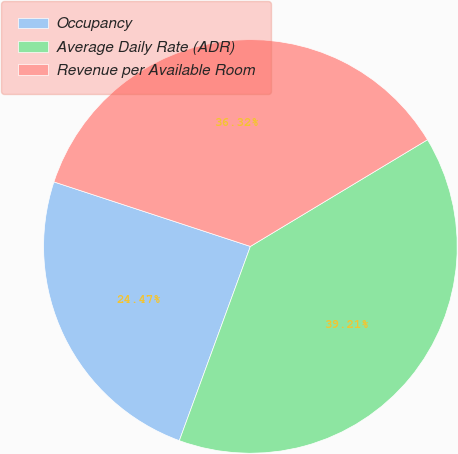Convert chart to OTSL. <chart><loc_0><loc_0><loc_500><loc_500><pie_chart><fcel>Occupancy<fcel>Average Daily Rate (ADR)<fcel>Revenue per Available Room<nl><fcel>24.47%<fcel>39.21%<fcel>36.32%<nl></chart> 